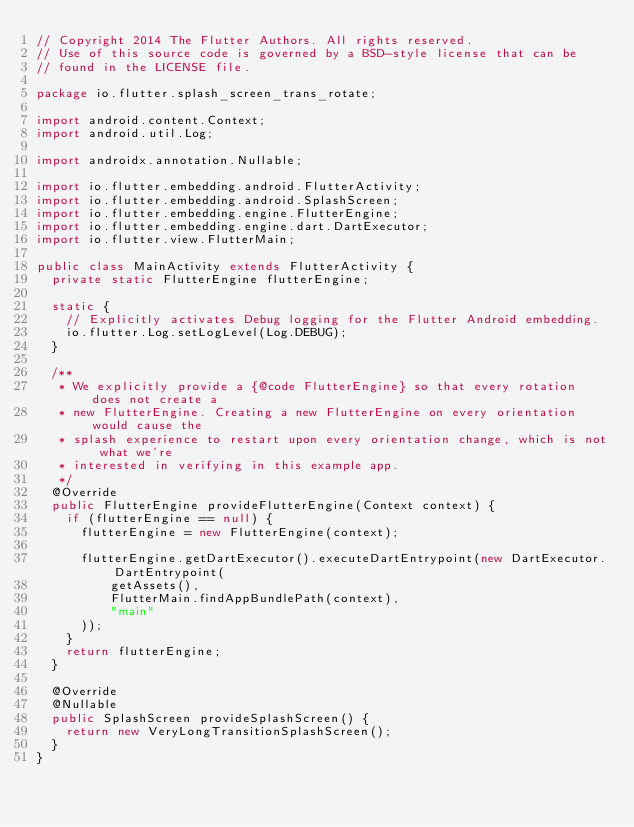Convert code to text. <code><loc_0><loc_0><loc_500><loc_500><_Java_>// Copyright 2014 The Flutter Authors. All rights reserved.
// Use of this source code is governed by a BSD-style license that can be
// found in the LICENSE file.

package io.flutter.splash_screen_trans_rotate;

import android.content.Context;
import android.util.Log;

import androidx.annotation.Nullable;

import io.flutter.embedding.android.FlutterActivity;
import io.flutter.embedding.android.SplashScreen;
import io.flutter.embedding.engine.FlutterEngine;
import io.flutter.embedding.engine.dart.DartExecutor;
import io.flutter.view.FlutterMain;

public class MainActivity extends FlutterActivity {
  private static FlutterEngine flutterEngine;

  static {
    // Explicitly activates Debug logging for the Flutter Android embedding.
    io.flutter.Log.setLogLevel(Log.DEBUG);
  }

  /**
   * We explicitly provide a {@code FlutterEngine} so that every rotation does not create a
   * new FlutterEngine. Creating a new FlutterEngine on every orientation would cause the
   * splash experience to restart upon every orientation change, which is not what we're
   * interested in verifying in this example app.
   */
  @Override
  public FlutterEngine provideFlutterEngine(Context context) {
    if (flutterEngine == null) {
      flutterEngine = new FlutterEngine(context);

      flutterEngine.getDartExecutor().executeDartEntrypoint(new DartExecutor.DartEntrypoint(
          getAssets(),
          FlutterMain.findAppBundlePath(context),
          "main"
      ));
    }
    return flutterEngine;
  }

  @Override
  @Nullable
  public SplashScreen provideSplashScreen() {
    return new VeryLongTransitionSplashScreen();
  }
}
</code> 